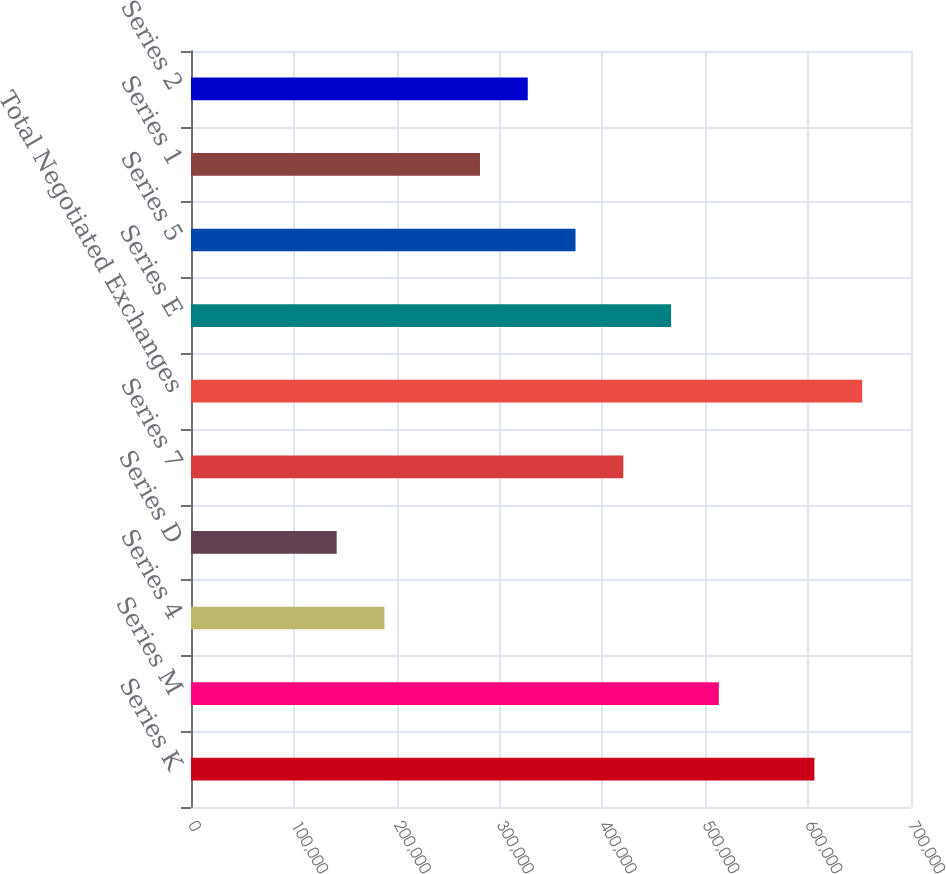Convert chart. <chart><loc_0><loc_0><loc_500><loc_500><bar_chart><fcel>Series K<fcel>Series M<fcel>Series 4<fcel>Series D<fcel>Series 7<fcel>Total Negotiated Exchanges<fcel>Series E<fcel>Series 5<fcel>Series 1<fcel>Series 2<nl><fcel>606065<fcel>513176<fcel>188066<fcel>141622<fcel>420288<fcel>652509<fcel>466732<fcel>373843<fcel>280955<fcel>327399<nl></chart> 